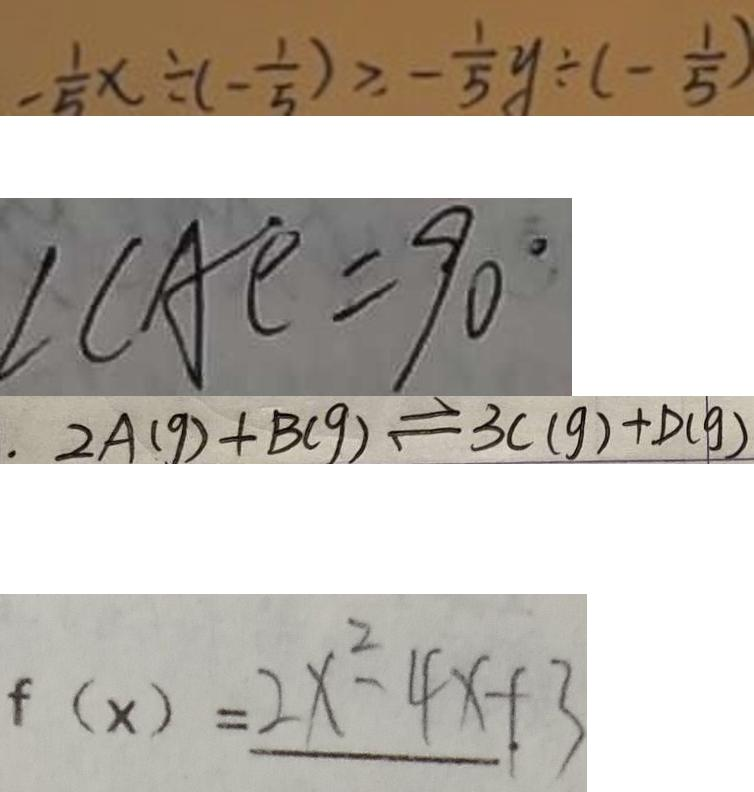<formula> <loc_0><loc_0><loc_500><loc_500>- \frac { 1 } { 5 } x \div ( - \frac { 1 } { 5 } ) \geq - \frac { 1 } { 5 } y \div ( - \frac { 1 } { 5 } ) 
 \angle C A E = 9 0 ^ { \circ } 
 2 A ( g ) + B ( g ) \rightleftharpoons 3 C ( g ) + D ( g ) 
 f ( x ) = 2 x ^ { 2 } - 4 x + 3</formula> 